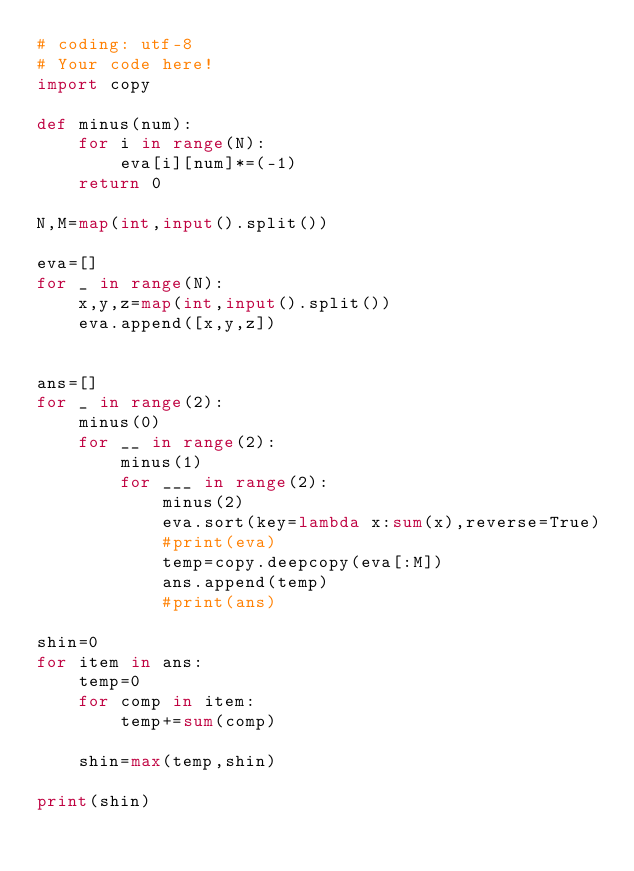Convert code to text. <code><loc_0><loc_0><loc_500><loc_500><_Python_># coding: utf-8
# Your code here!
import copy

def minus(num):
    for i in range(N):
        eva[i][num]*=(-1)
    return 0

N,M=map(int,input().split())

eva=[]
for _ in range(N):
    x,y,z=map(int,input().split())
    eva.append([x,y,z])
    

ans=[]
for _ in range(2):
    minus(0)
    for __ in range(2):
        minus(1)
        for ___ in range(2):
            minus(2)
            eva.sort(key=lambda x:sum(x),reverse=True)
            #print(eva)
            temp=copy.deepcopy(eva[:M])
            ans.append(temp)
            #print(ans)
            
shin=0
for item in ans:
    temp=0
    for comp in item:
        temp+=sum(comp)
        
    shin=max(temp,shin)
    
print(shin)</code> 